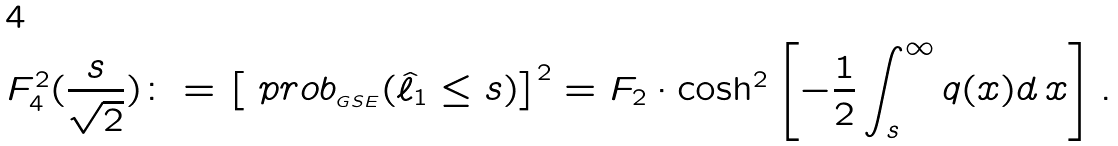Convert formula to latex. <formula><loc_0><loc_0><loc_500><loc_500>F _ { 4 } ^ { 2 } ( \frac { s } { \sqrt { 2 } } ) \colon = \left [ \ p r o b _ { _ { G S E } } ( \hat { \ell } _ { 1 } \leq s ) \right ] ^ { 2 } = F _ { 2 } \cdot \cosh ^ { 2 } \left [ - \frac { 1 } { 2 } \int _ { s } ^ { \infty } q ( x ) d \, x \right ] .</formula> 